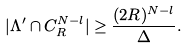<formula> <loc_0><loc_0><loc_500><loc_500>| \Lambda ^ { \prime } \cap C _ { R } ^ { N - l } | \geq \frac { ( 2 R ) ^ { N - l } } { \Delta } .</formula> 